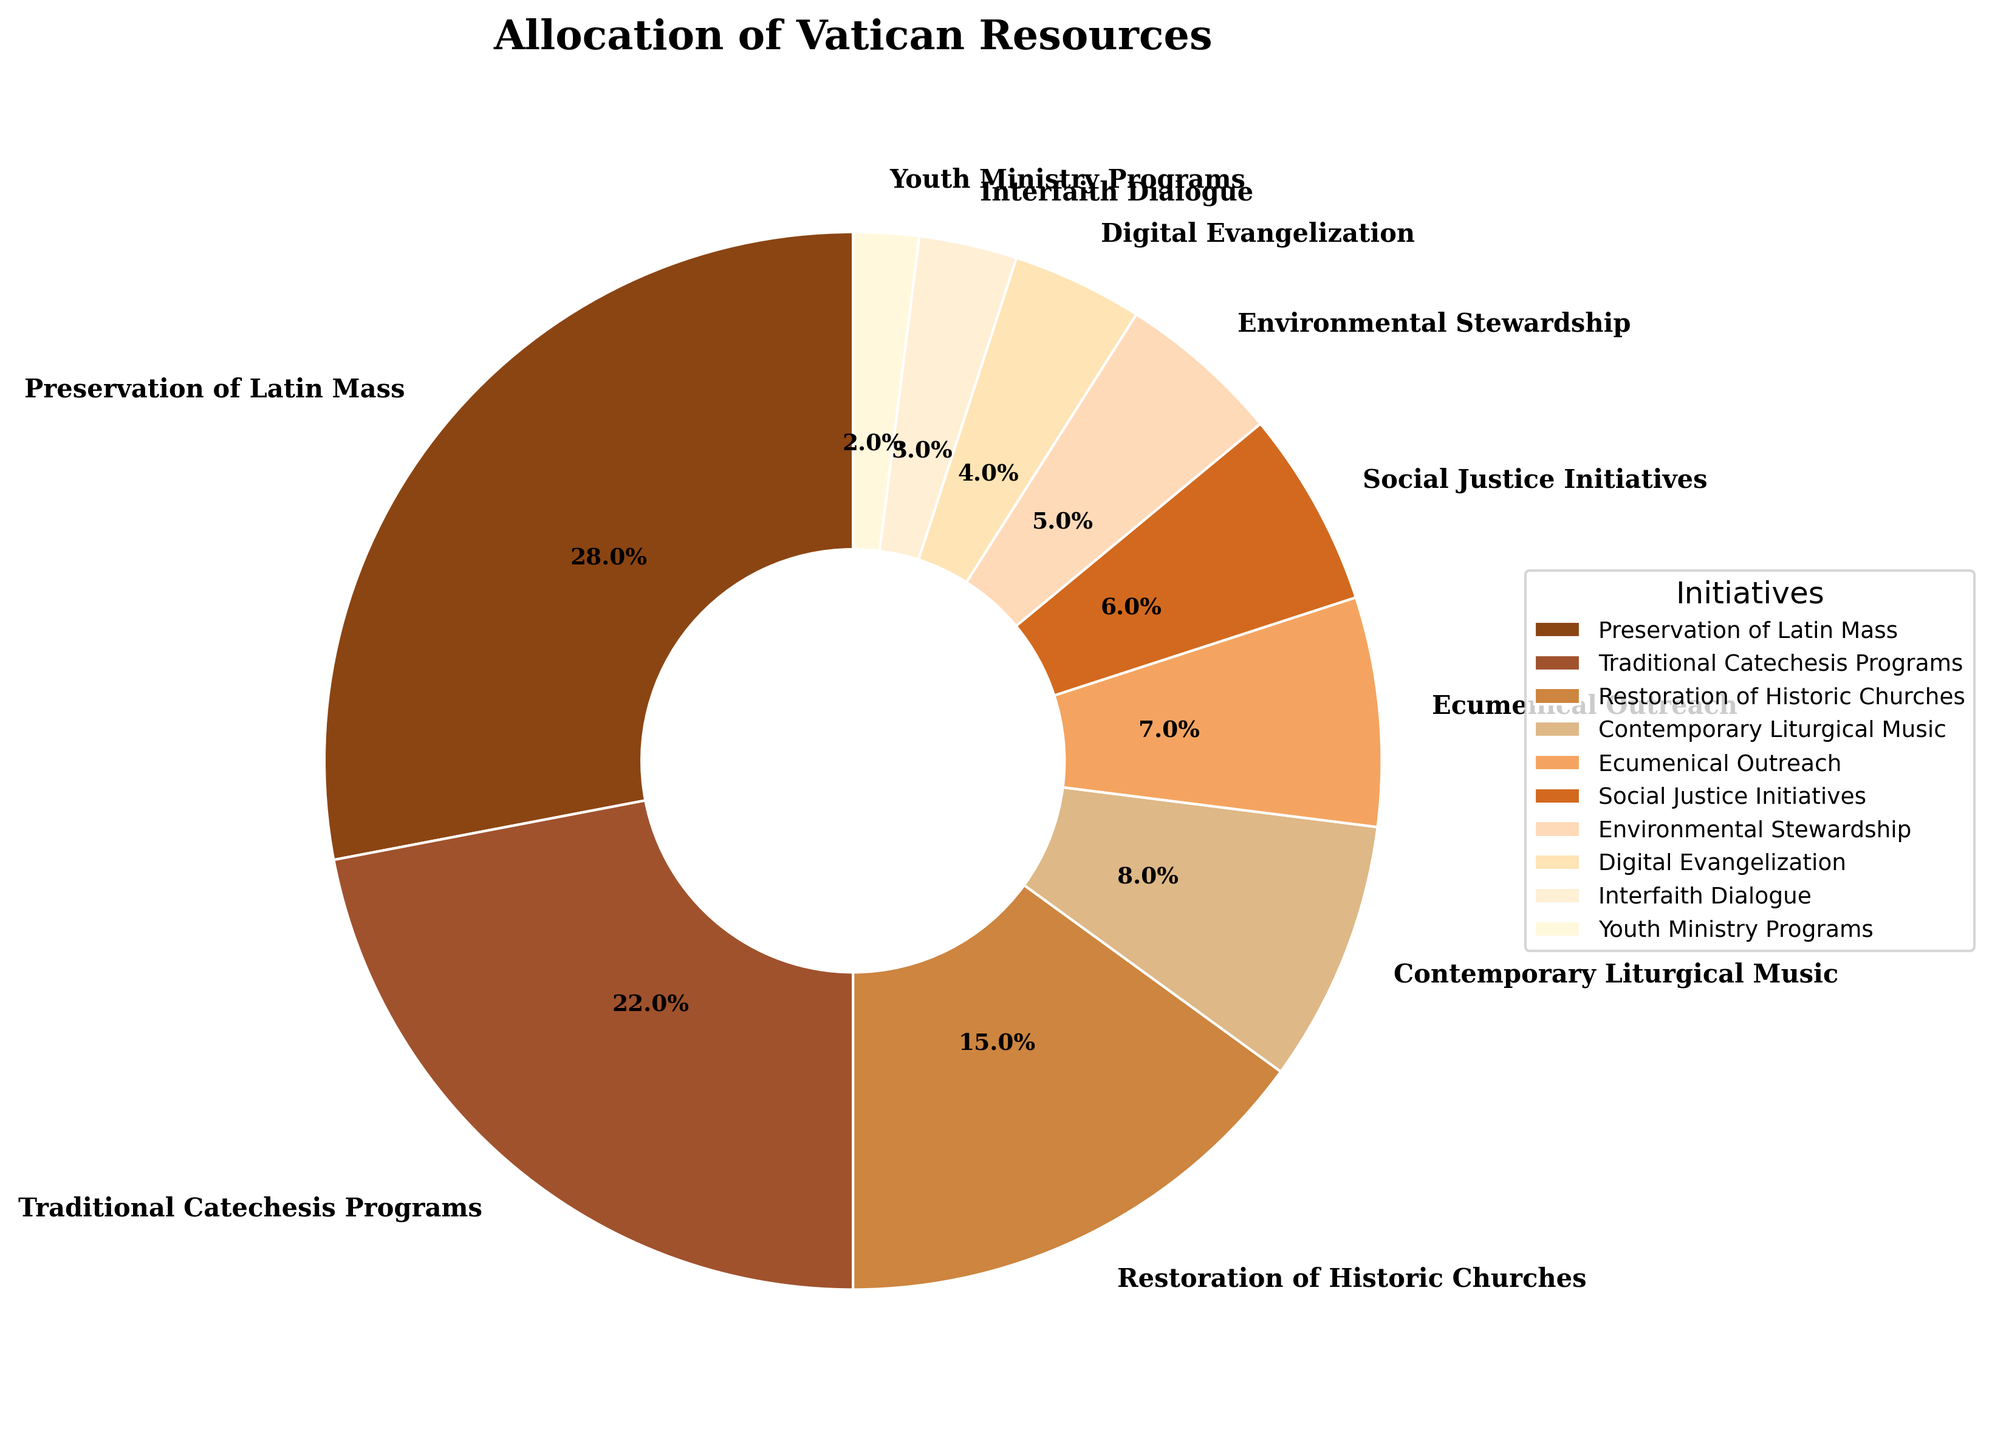What percentage of the Vatican resources are allocated to initiatives related to traditional practices? To determine this, we need to sum the percentages of the initiatives classified under traditional practices, namely 'Preservation of Latin Mass' (28%), 'Traditional Catechesis Programs' (22%), and 'Restoration of Historic Churches' (15%). Adding these together gives: 28 + 22 + 15 = 65%
Answer: 65% How does the allocation to contemporary initiatives compare to traditional initiatives? Contemporary initiatives include 'Contemporary Liturgical Music' (8%), 'Ecumenical Outreach' (7%), 'Social Justice Initiatives' (6%), 'Environmental Stewardship' (5%), 'Digital Evangelization' (4%), 'Interfaith Dialogue' (3%), and 'Youth Ministry Programs' (2%), which together total: 8 + 7 + 6 + 5 + 4 + 3 + 2 = 35%. The allocation for traditional initiatives is 65%. Thus, traditional initiatives receive significantly more resources than contemporary ones.
Answer: Traditional initiatives receive more resources (65% vs 35%) Which initiative receives the most resources according to the pie chart? By looking at the pie chart, the slice representing the 'Preservation of Latin Mass' is the largest, indicating it receives the most resources.
Answer: Preservation of Latin Mass How much more percentage is allocated to 'Preservation of Latin Mass' compared to 'Traditional Catechesis Programs'? Subtract the percentage of 'Traditional Catechesis Programs' (22%) from that of 'Preservation of Latin Mass' (28%): 28 - 22 = 6%.
Answer: 6% Which initiatives collectively make up less than 10% of the allocation? The initiatives with the following percentages collectively make up less than 10%: ‘Youth Ministry Programs’ (2%), ‘Interfaith Dialogue’ (3%), and ‘Digital Evangelization’ (4%). Summing these values: 2 + 3 + 4 = 9%.
Answer: Youth Ministry Programs, Interfaith Dialogue, and Digital Evangelization Is the allocation to 'Environmental Stewardship' greater than that to 'Social Justice Initiatives'? By comparing the pie chart sections, 'Environmental Stewardship' has 5% while 'Social Justice Initiatives' has 6%. Therefore, 'Environmental Stewardship' is allocated less than 'Social Justice Initiatives'.
Answer: No What is the difference between the highest allocated initiative and the least allocated initiative? The highest allocated initiative is ‘Preservation of Latin Mass’ with 28%, and the least allocated is ‘Youth Ministry Programs’ with 2%. The difference is 28 - 2 = 26%.
Answer: 26% Are there more resources allocated to 'Traditional Catechesis Programs' or 'Restoration of Historic Churches'? Comparing the pie chart sections, 'Traditional Catechesis Programs' is allocated 22% while 'Restoration of Historic Churches' is allocated 15%. Therefore, more resources are allocated to 'Traditional Catechesis Programs'.
Answer: Traditional Catechesis Programs If 'Social Justice Initiatives' and 'Environmental Stewardship' were combined, would their total allocation exceed that of 'Traditional Catechesis Programs'? 'Social Justice Initiatives' has 6% and 'Environmental Stewardship' has 5%. Combined, they total: 6 + 5 = 11%. This is less than ‘Traditional Catechesis Programs’ which has 22%.
Answer: No How do 'Ecumenical Outreach' and 'Contemporary Liturgical Music' allocations compare visually? In the pie chart, the segment for 'Contemporary Liturgical Music' (8%) is larger than the segment for 'Ecumenical Outreach' (7%), indicating more resources are allocated to 'Contemporary Liturgical Music'.
Answer: Contemporary Liturgical Music receives more resources 